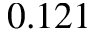Convert formula to latex. <formula><loc_0><loc_0><loc_500><loc_500>0 . 1 2 1</formula> 